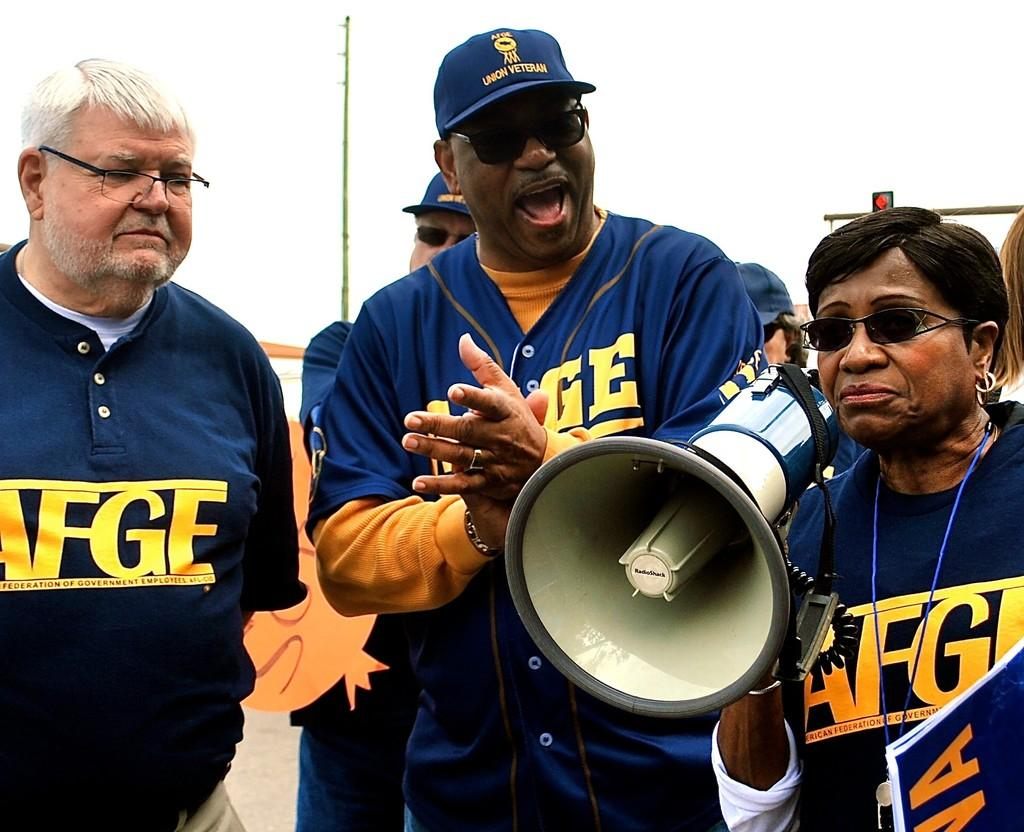<image>
Offer a succinct explanation of the picture presented. A group of American Federation of Government Employees gather together. 